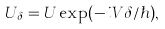Convert formula to latex. <formula><loc_0><loc_0><loc_500><loc_500>U _ { \delta } = U \exp ( - i V \delta / \hbar { ) } ,</formula> 